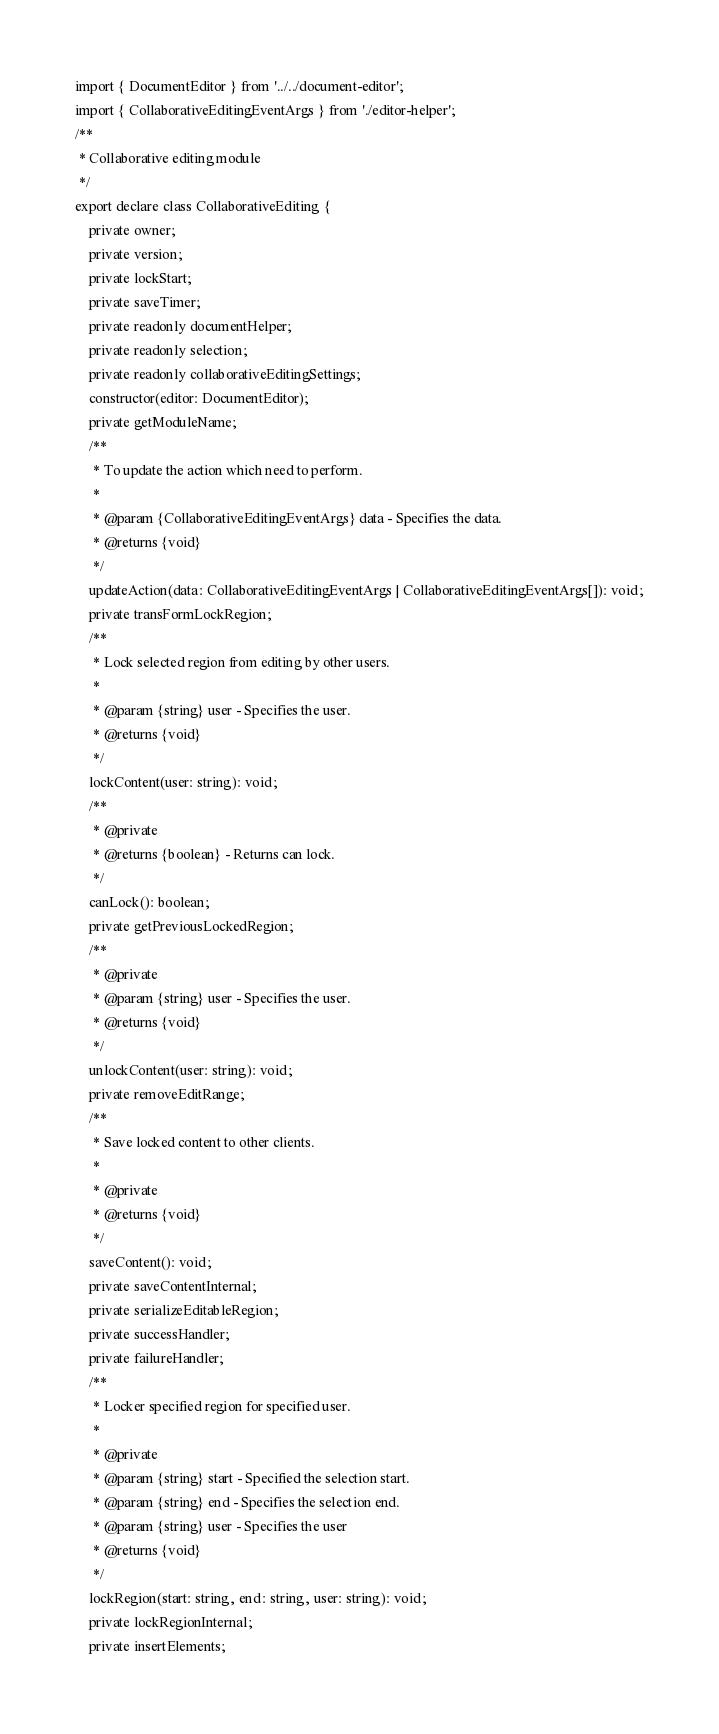Convert code to text. <code><loc_0><loc_0><loc_500><loc_500><_TypeScript_>import { DocumentEditor } from '../../document-editor';
import { CollaborativeEditingEventArgs } from './editor-helper';
/**
 * Collaborative editing module
 */
export declare class CollaborativeEditing {
    private owner;
    private version;
    private lockStart;
    private saveTimer;
    private readonly documentHelper;
    private readonly selection;
    private readonly collaborativeEditingSettings;
    constructor(editor: DocumentEditor);
    private getModuleName;
    /**
     * To update the action which need to perform.
     *
     * @param {CollaborativeEditingEventArgs} data - Specifies the data.
     * @returns {void}
     */
    updateAction(data: CollaborativeEditingEventArgs | CollaborativeEditingEventArgs[]): void;
    private transFormLockRegion;
    /**
     * Lock selected region from editing by other users.
     *
     * @param {string} user - Specifies the user.
     * @returns {void}
     */
    lockContent(user: string): void;
    /**
     * @private
     * @returns {boolean} - Returns can lock.
     */
    canLock(): boolean;
    private getPreviousLockedRegion;
    /**
     * @private
     * @param {string} user - Specifies the user.
     * @returns {void}
     */
    unlockContent(user: string): void;
    private removeEditRange;
    /**
     * Save locked content to other clients.
     *
     * @private
     * @returns {void}
     */
    saveContent(): void;
    private saveContentInternal;
    private serializeEditableRegion;
    private successHandler;
    private failureHandler;
    /**
     * Locker specified region for specified user.
     *
     * @private
     * @param {string} start - Specified the selection start.
     * @param {string} end - Specifies the selection end.
     * @param {string} user - Specifies the user
     * @returns {void}
     */
    lockRegion(start: string, end: string, user: string): void;
    private lockRegionInternal;
    private insertElements;</code> 